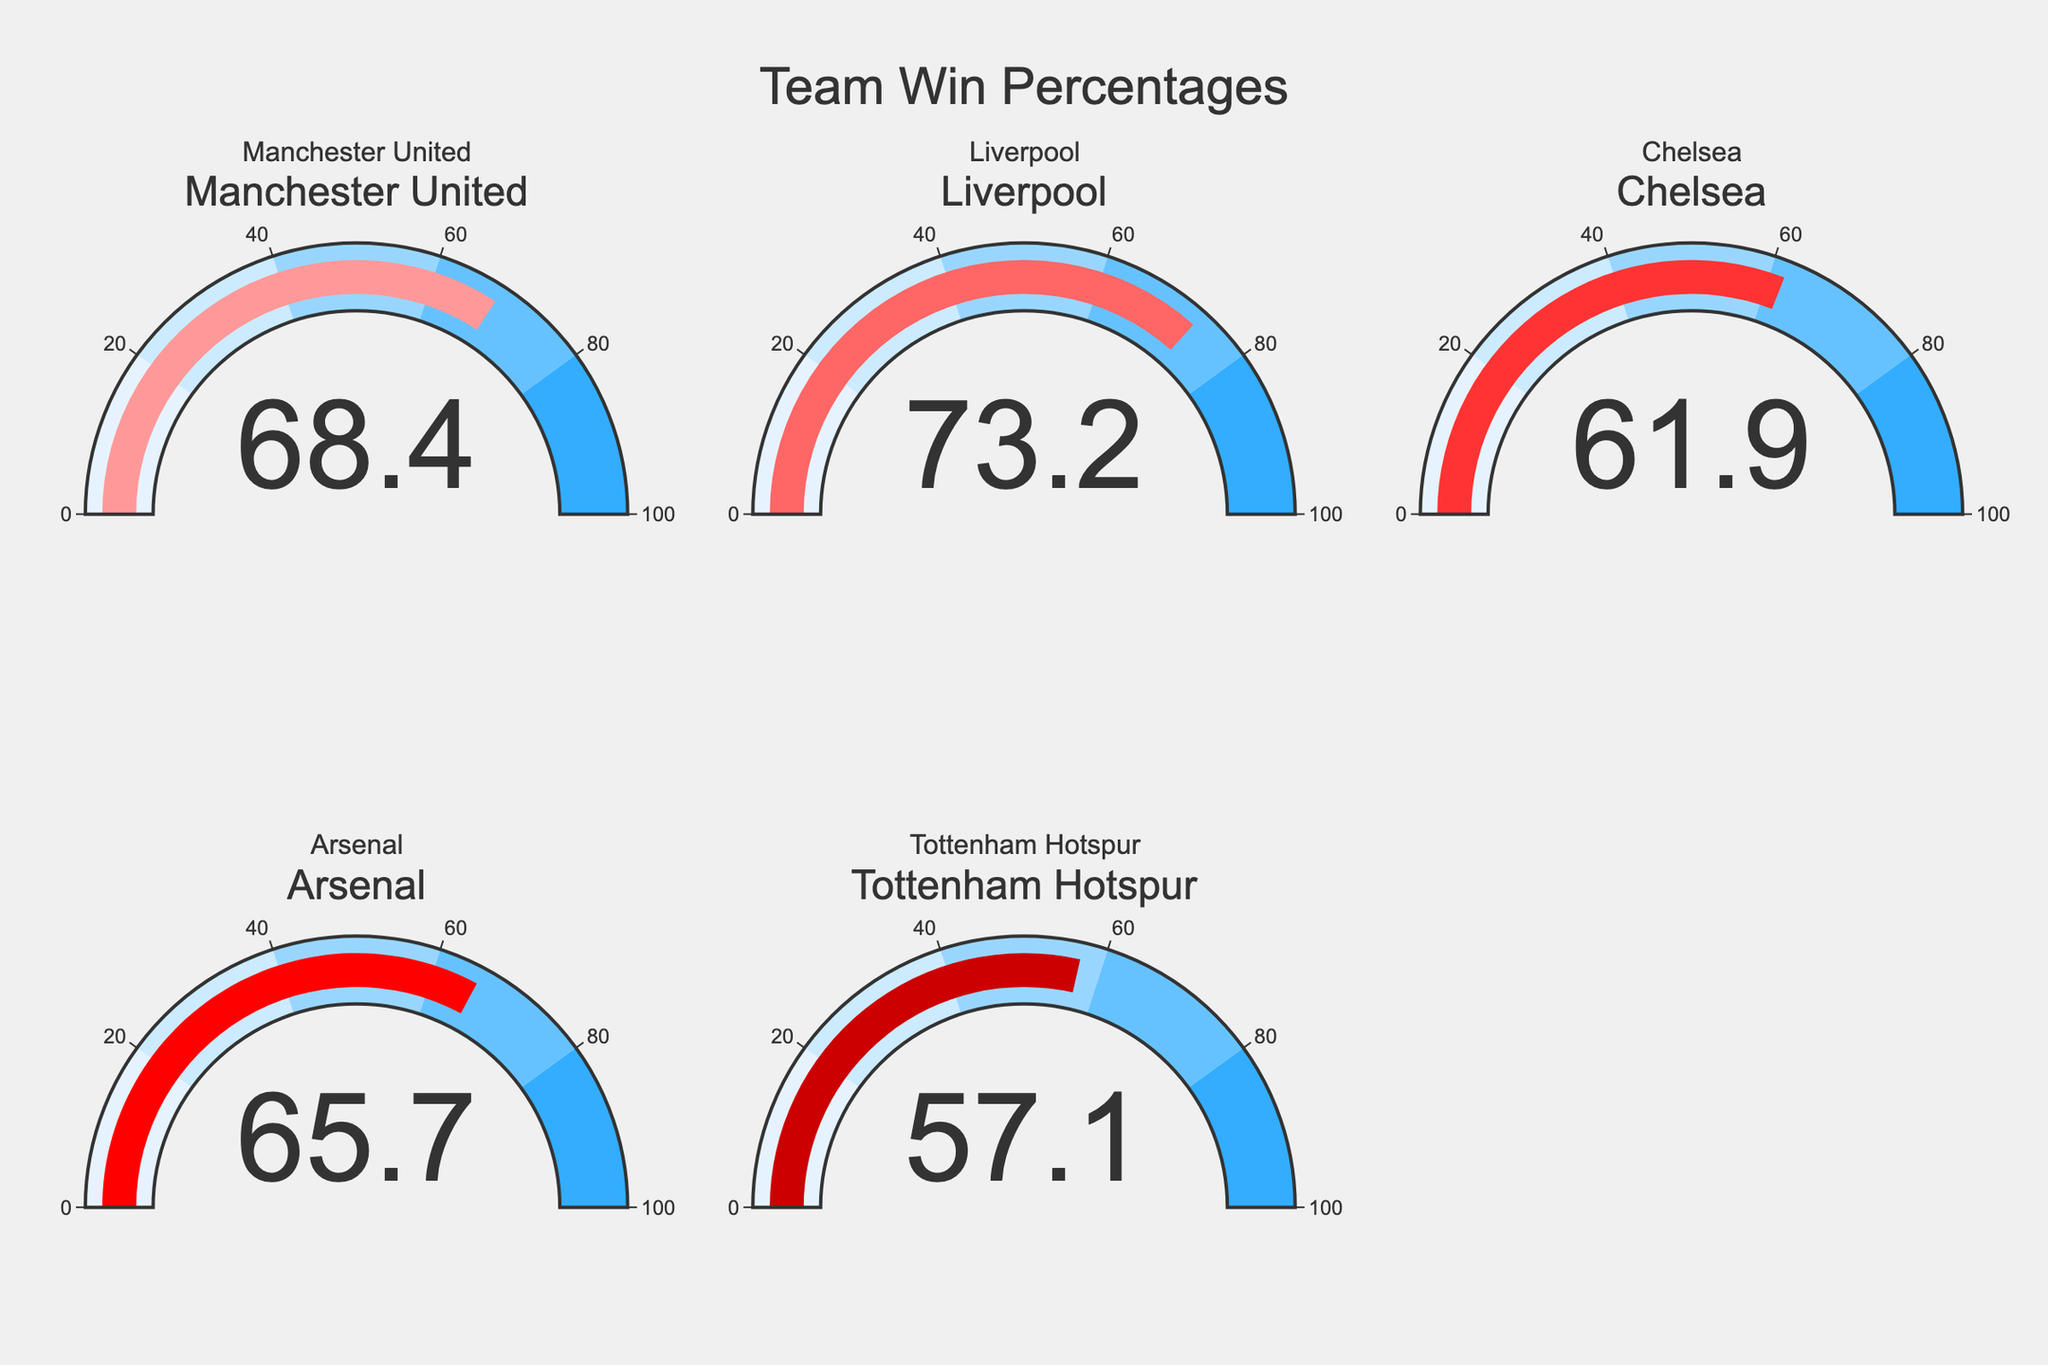What's the title of the figure? The title is displayed at the top center of the figure. It reads "Team Win Percentages".
Answer: Team Win Percentages Which team has the highest win percentage? Focus on the gauges and find the team with the highest numerical value. Liverpool has the highest win percentage at 73.2%.
Answer: Liverpool Which team has the lowest win percentage? Compare the win percentages for all the teams. Tottenham Hotspur has the lowest win percentage at 57.1%.
Answer: Tottenham Hotspur What is the average win percentage of all teams? Add up the win percentages of all the teams and divide by the number of teams: (68.4 + 73.2 + 61.9 + 65.7 + 57.1) / 5 = 65.26.
Answer: 65.26 What's the color of the gauge for Arsenal? Identify the color of Arsenal's gauge. According to the color scale, it's a shade of red (#FF0000).
Answer: Red What is the difference in win percentage between the team with the highest and the team with the lowest win percentages? Subtract the lowest win percentage from the highest win percentage: 73.2 - 57.1 = 16.1.
Answer: 16.1 Which teams have a win percentage greater than 60%? Check each team's win percentage and identify those above 60%. The teams are Manchester United, Liverpool, Chelsea, and Arsenal.
Answer: Manchester United, Liverpool, Chelsea, Arsenal What is the median win percentage of the teams? List the win percentages in ascending order (57.1, 61.9, 65.7, 68.4, 73.2) and find the middle value. The median win percentage is 65.7.
Answer: 65.7 Which two teams have win percentages closest to each other? Compare the differences between each team's win percentages: Manchester United (68.4) and Arsenal (65.7) have the smallest difference of 2.7.
Answer: Manchester United and Arsenal How many gauges are shown in the first row of the subplots? Observe the number of gauges in the first row, there are three gauges.
Answer: 3 